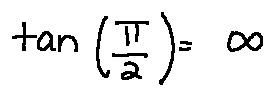Convert formula to latex. <formula><loc_0><loc_0><loc_500><loc_500>\tan ( \frac { \pi } { 2 } ) = \infty</formula> 